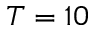Convert formula to latex. <formula><loc_0><loc_0><loc_500><loc_500>T = 1 0</formula> 